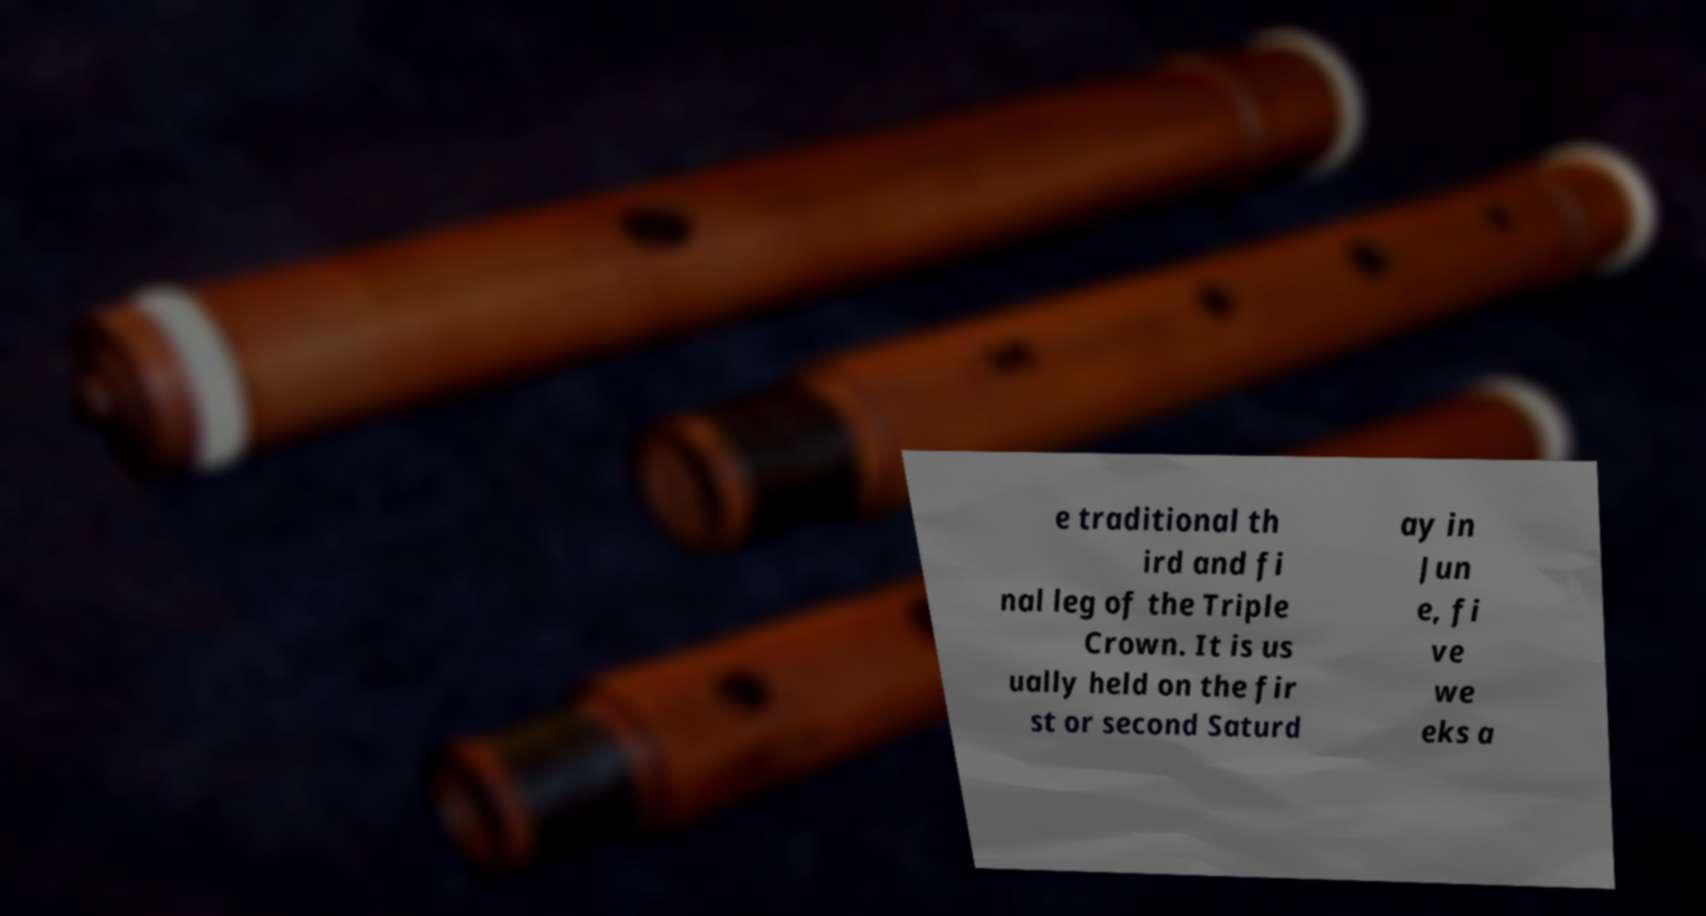Please read and relay the text visible in this image. What does it say? e traditional th ird and fi nal leg of the Triple Crown. It is us ually held on the fir st or second Saturd ay in Jun e, fi ve we eks a 